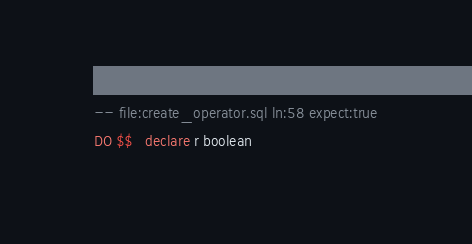<code> <loc_0><loc_0><loc_500><loc_500><_SQL_>-- file:create_operator.sql ln:58 expect:true
DO $$   declare r boolean
</code> 